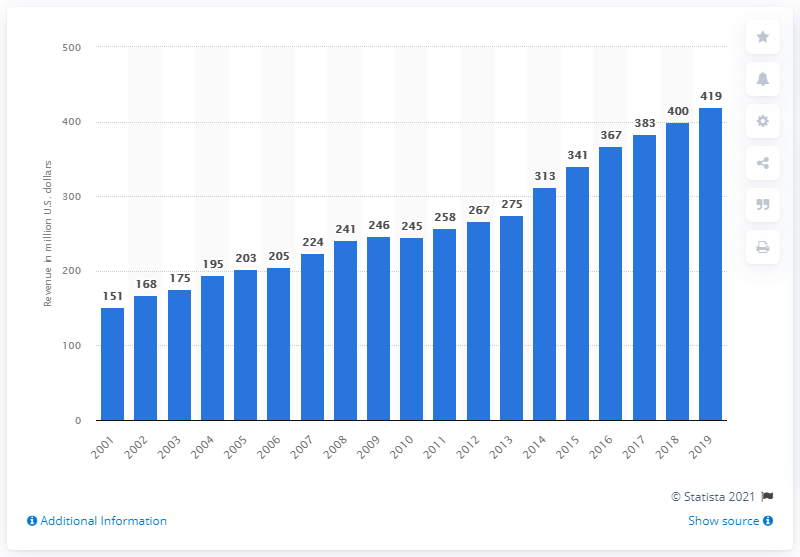What was the revenue of the Tampa Bay Buccaneers in 2019? In 2019, the Tampa Bay Buccaneers generated a revenue of $419 million, experiencing a significant growth compared to previous years. This increase reflects various factors including enhanced marketing strategies, greater game attendance, and increased sales from merchandise. 